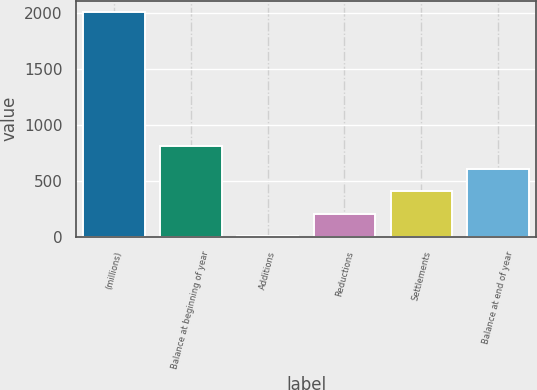<chart> <loc_0><loc_0><loc_500><loc_500><bar_chart><fcel>(millions)<fcel>Balance at beginning of year<fcel>Additions<fcel>Reductions<fcel>Settlements<fcel>Balance at end of year<nl><fcel>2013<fcel>810.6<fcel>9<fcel>209.4<fcel>409.8<fcel>610.2<nl></chart> 